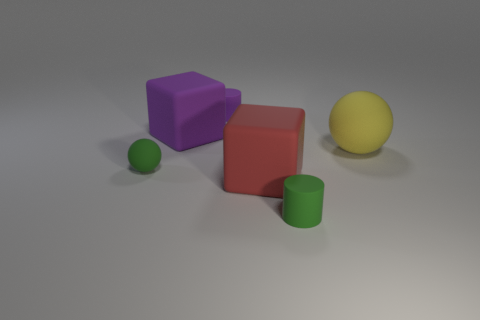Add 1 rubber things. How many objects exist? 7 Subtract all cylinders. How many objects are left? 4 Add 2 green spheres. How many green spheres are left? 3 Add 1 tiny green cylinders. How many tiny green cylinders exist? 2 Subtract 0 blue cubes. How many objects are left? 6 Subtract all brown metal cylinders. Subtract all purple matte blocks. How many objects are left? 5 